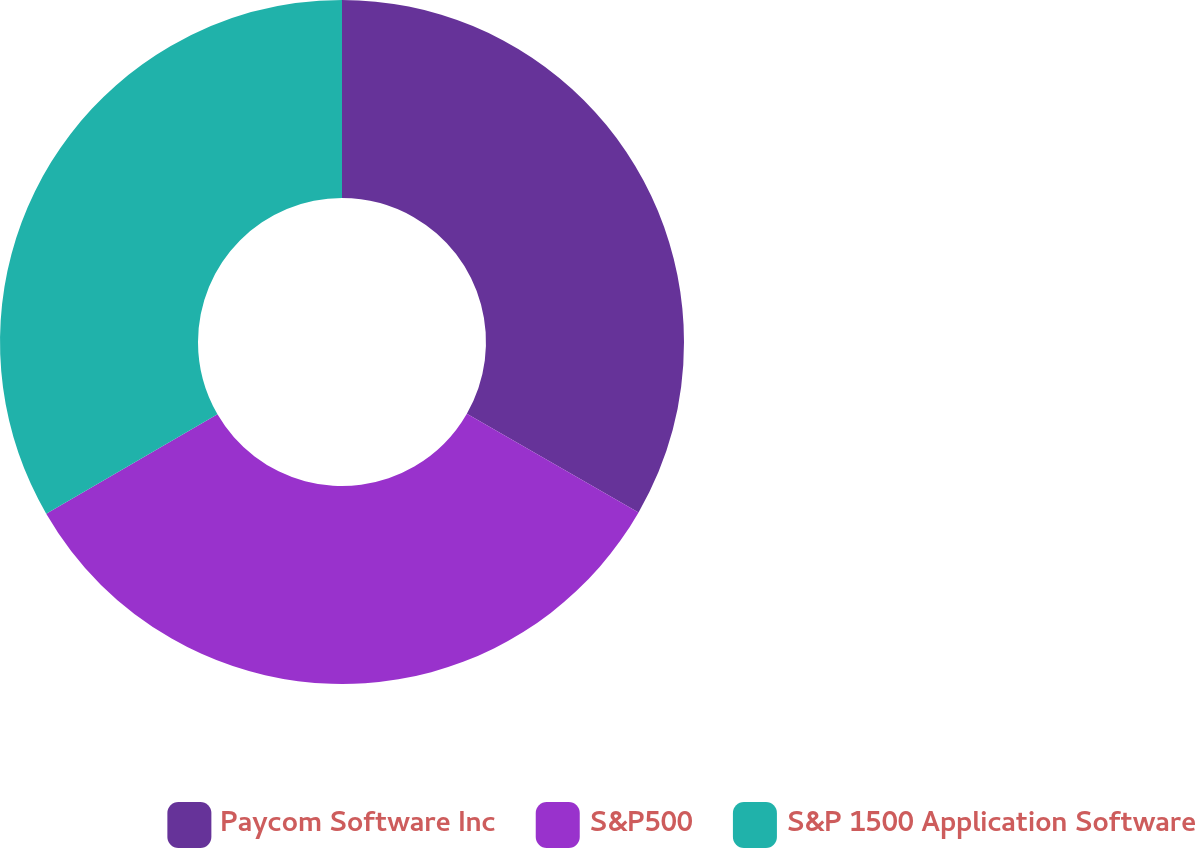Convert chart. <chart><loc_0><loc_0><loc_500><loc_500><pie_chart><fcel>Paycom Software Inc<fcel>S&P500<fcel>S&P 1500 Application Software<nl><fcel>33.3%<fcel>33.33%<fcel>33.37%<nl></chart> 